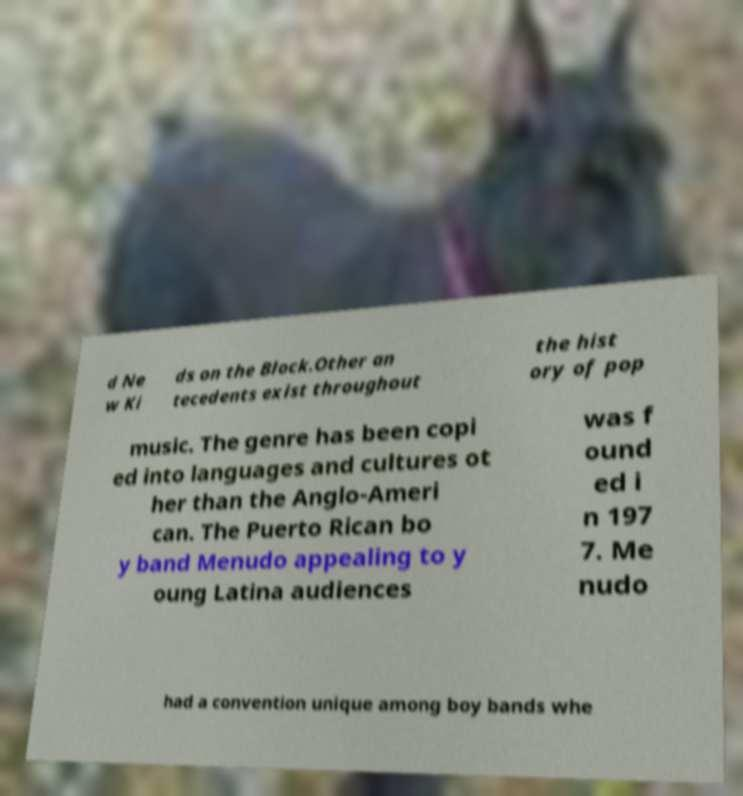Could you assist in decoding the text presented in this image and type it out clearly? d Ne w Ki ds on the Block.Other an tecedents exist throughout the hist ory of pop music. The genre has been copi ed into languages and cultures ot her than the Anglo-Ameri can. The Puerto Rican bo y band Menudo appealing to y oung Latina audiences was f ound ed i n 197 7. Me nudo had a convention unique among boy bands whe 